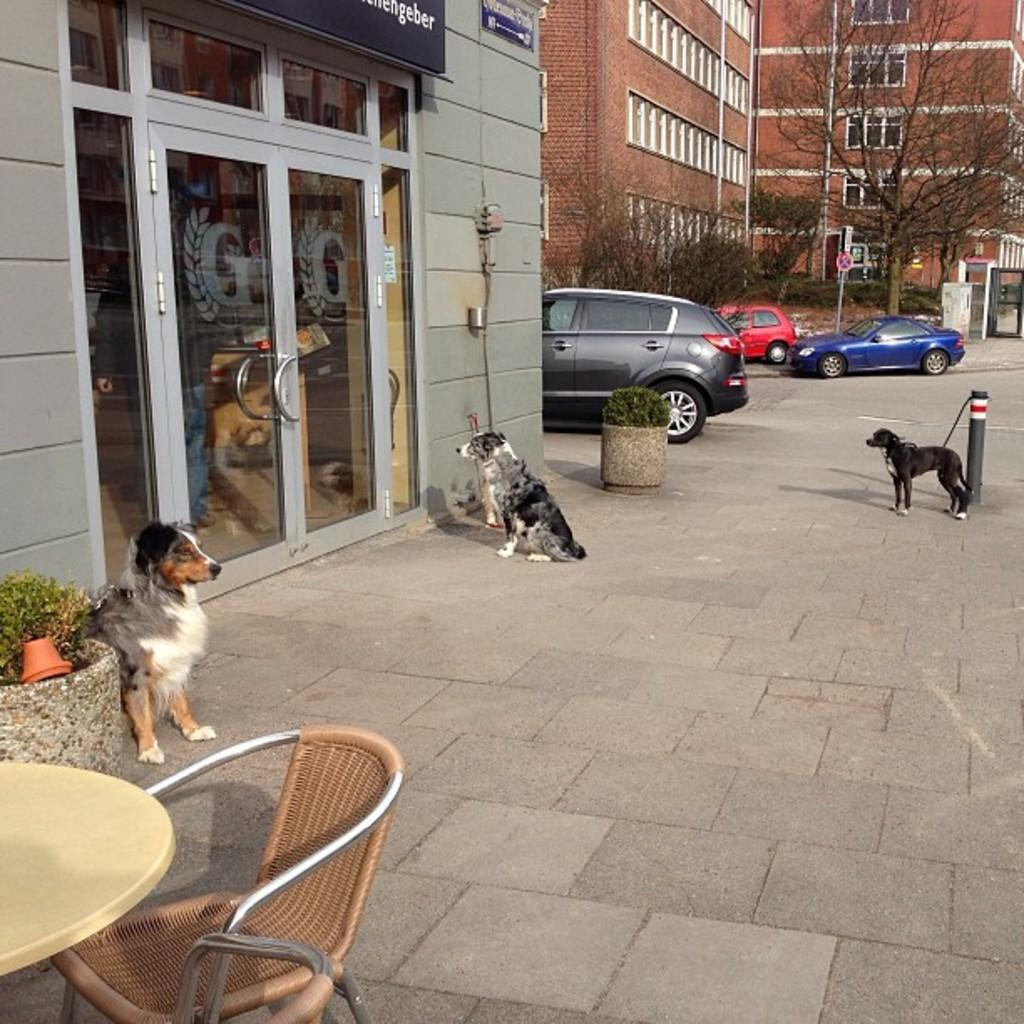What animals can be seen in the image? There are dogs in the image. What type of vehicles are on the road in the image? There are cars on the road in the image. What furniture is located on the left side of the image? There is a table and a chair on the left side of the image. What can be seen in the background of the image? There are trees and a building in the background of the image. How many bells are hanging from the trees in the image? There are no bells visible in the image; only trees and a building can be seen in the background. 